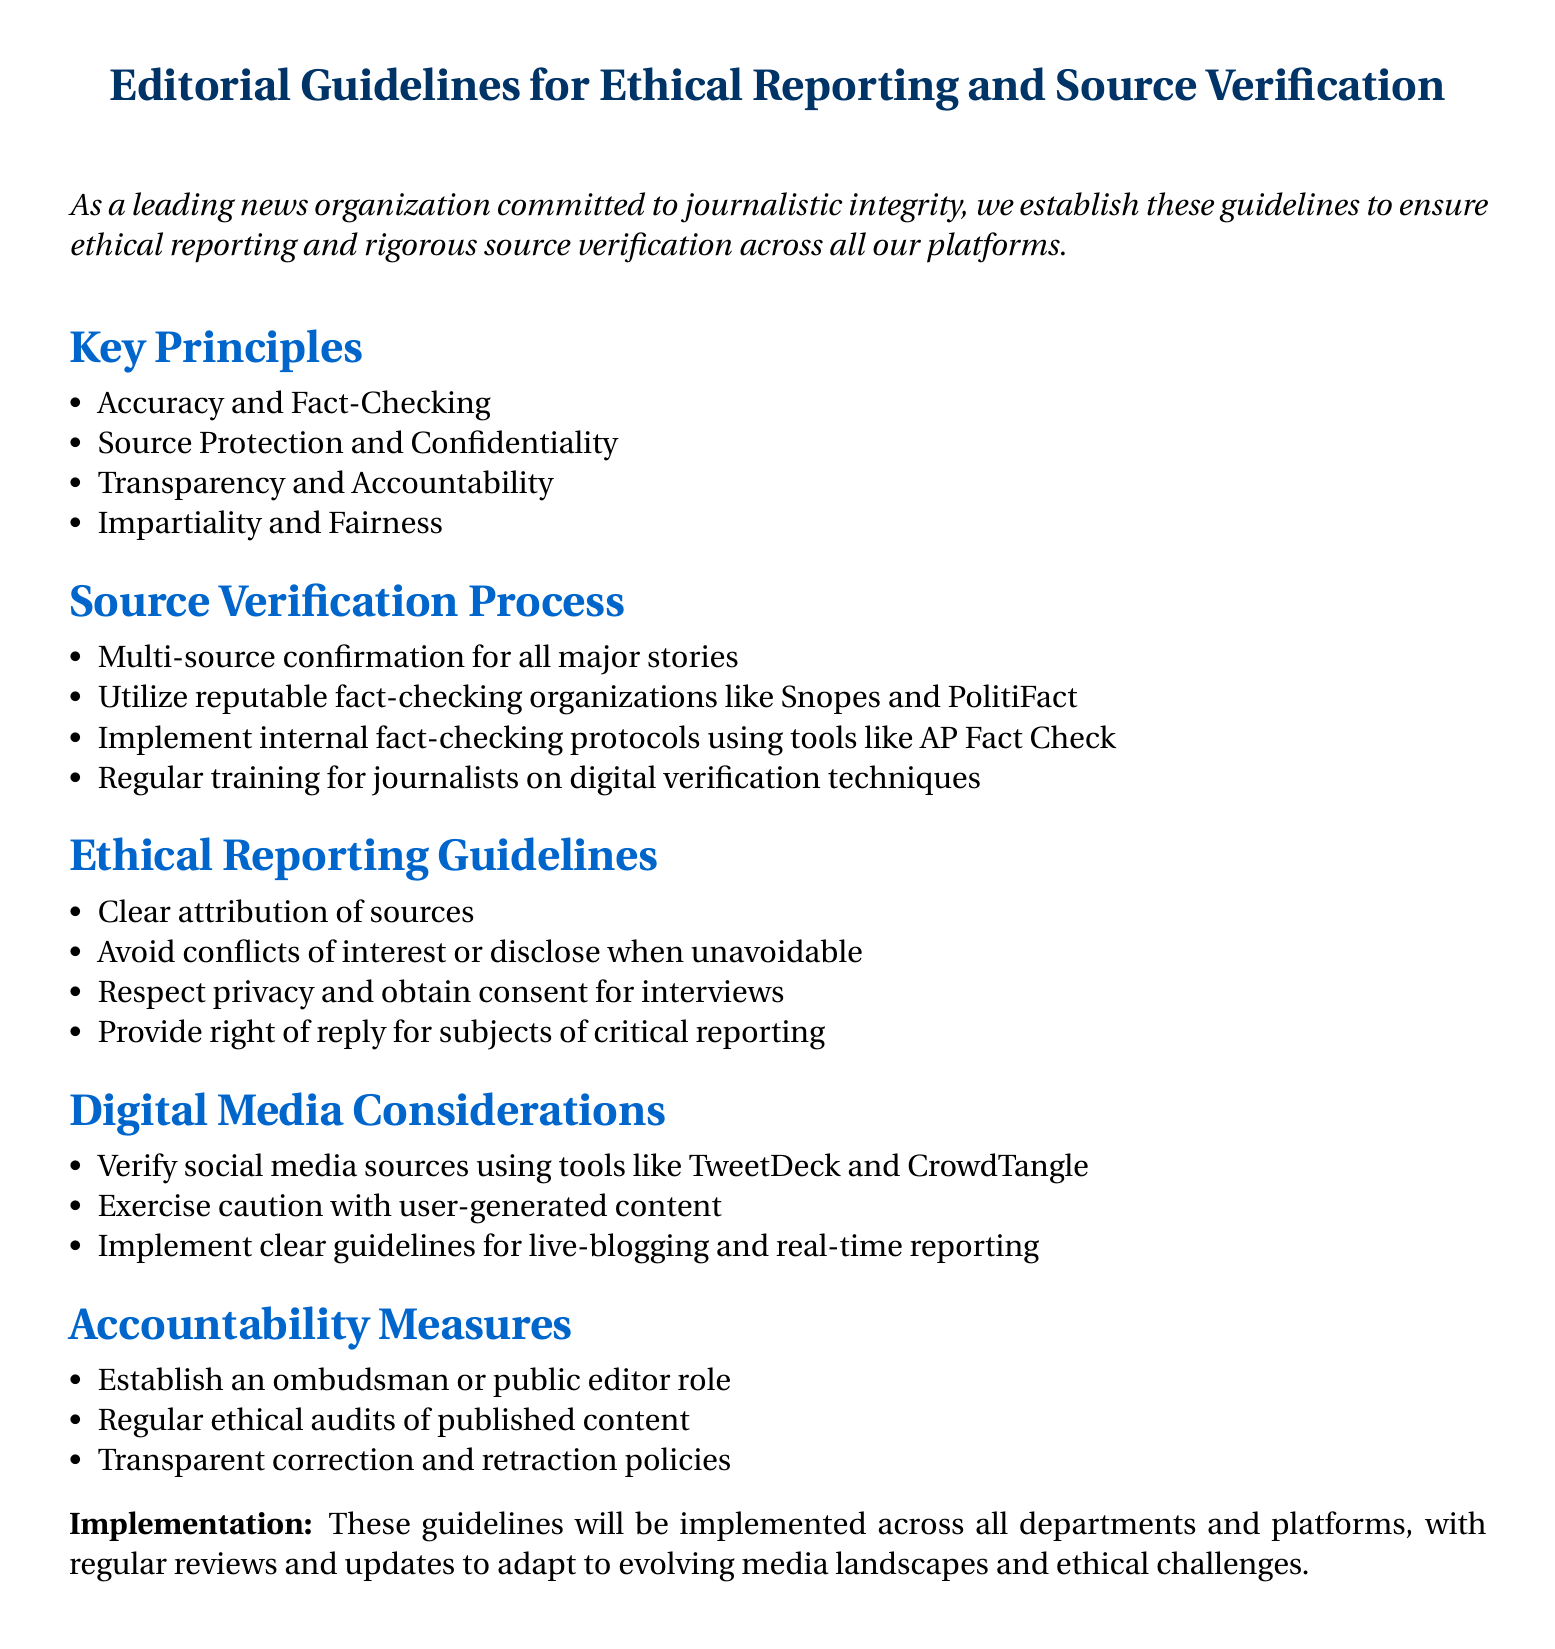What is the title of the document? The title is explicitly stated at the beginning of the document.
Answer: Editorial Guidelines for Ethical Reporting and Source Verification How many key principles are listed? The number of key principles can be counted in the list provided.
Answer: Four What should be used for multi-source confirmation? This is specified in the source verification process section of the document.
Answer: Major stories Which organizations are suggested for reputable fact-checking? The document names specific organizations in the source verification process.
Answer: Snopes and PolitiFact What is mentioned to respect privacy? This is an ethical guideline related to respecting individuals during reporting.
Answer: Obtain consent for interviews What does the document suggest to verify social media sources? This is specified in the digital media considerations section of the document.
Answer: Tools like TweetDeck and CrowdTangle What role is established for accountability measures? The document describes a specific role for accountability within the organization.
Answer: Ombudsman What is the purpose of regular ethical audits? The document suggests this measure to evaluate content.
Answer: Published content What must be provided for subjects of critical reporting? This reflects an ethical standard in reporting practices.
Answer: Right of reply for subjects 